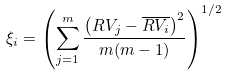<formula> <loc_0><loc_0><loc_500><loc_500>\xi _ { i } = \left ( \sum _ { j = 1 } ^ { m } \frac { \left ( R V _ { j } - \overline { R V _ { i } } \right ) ^ { 2 } } { m ( m - 1 ) } \right ) ^ { 1 / 2 }</formula> 